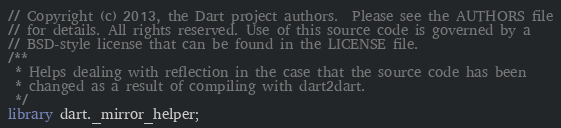<code> <loc_0><loc_0><loc_500><loc_500><_Dart_>// Copyright (c) 2013, the Dart project authors.  Please see the AUTHORS file
// for details. All rights reserved. Use of this source code is governed by a
// BSD-style license that can be found in the LICENSE file.
/**
 * Helps dealing with reflection in the case that the source code has been
 * changed as a result of compiling with dart2dart.
 */
library dart._mirror_helper;
</code> 